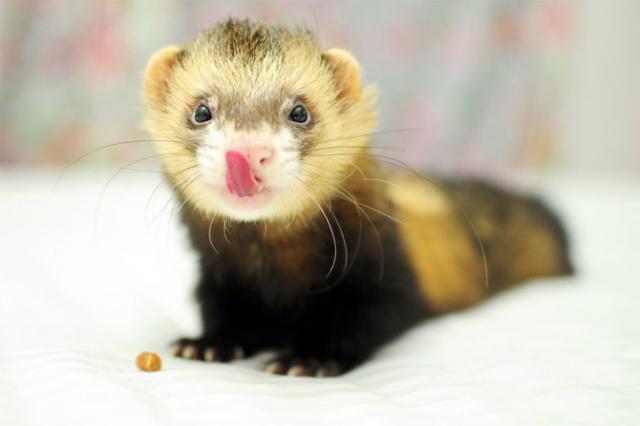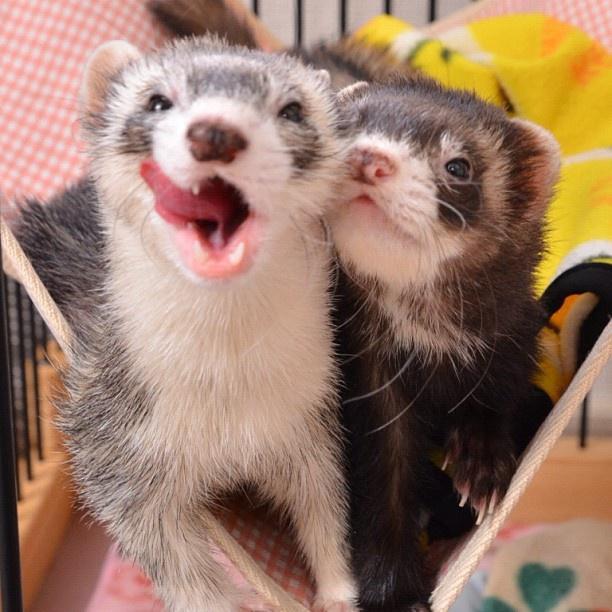The first image is the image on the left, the second image is the image on the right. Analyze the images presented: Is the assertion "At least one of the ferrets has their tongue sticking out." valid? Answer yes or no. Yes. The first image is the image on the left, the second image is the image on the right. Assess this claim about the two images: "At least one ferret has an open mouth with tongue showing, and a total of three ferrets are shown.". Correct or not? Answer yes or no. Yes. 